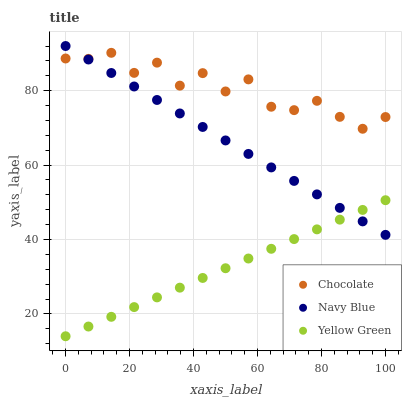Does Yellow Green have the minimum area under the curve?
Answer yes or no. Yes. Does Chocolate have the maximum area under the curve?
Answer yes or no. Yes. Does Chocolate have the minimum area under the curve?
Answer yes or no. No. Does Yellow Green have the maximum area under the curve?
Answer yes or no. No. Is Yellow Green the smoothest?
Answer yes or no. Yes. Is Chocolate the roughest?
Answer yes or no. Yes. Is Chocolate the smoothest?
Answer yes or no. No. Is Yellow Green the roughest?
Answer yes or no. No. Does Yellow Green have the lowest value?
Answer yes or no. Yes. Does Chocolate have the lowest value?
Answer yes or no. No. Does Navy Blue have the highest value?
Answer yes or no. Yes. Does Chocolate have the highest value?
Answer yes or no. No. Is Yellow Green less than Chocolate?
Answer yes or no. Yes. Is Chocolate greater than Yellow Green?
Answer yes or no. Yes. Does Yellow Green intersect Navy Blue?
Answer yes or no. Yes. Is Yellow Green less than Navy Blue?
Answer yes or no. No. Is Yellow Green greater than Navy Blue?
Answer yes or no. No. Does Yellow Green intersect Chocolate?
Answer yes or no. No. 